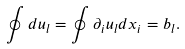Convert formula to latex. <formula><loc_0><loc_0><loc_500><loc_500>\oint d u _ { l } = \oint \partial _ { i } u _ { l } d x _ { i } = b _ { l } .</formula> 